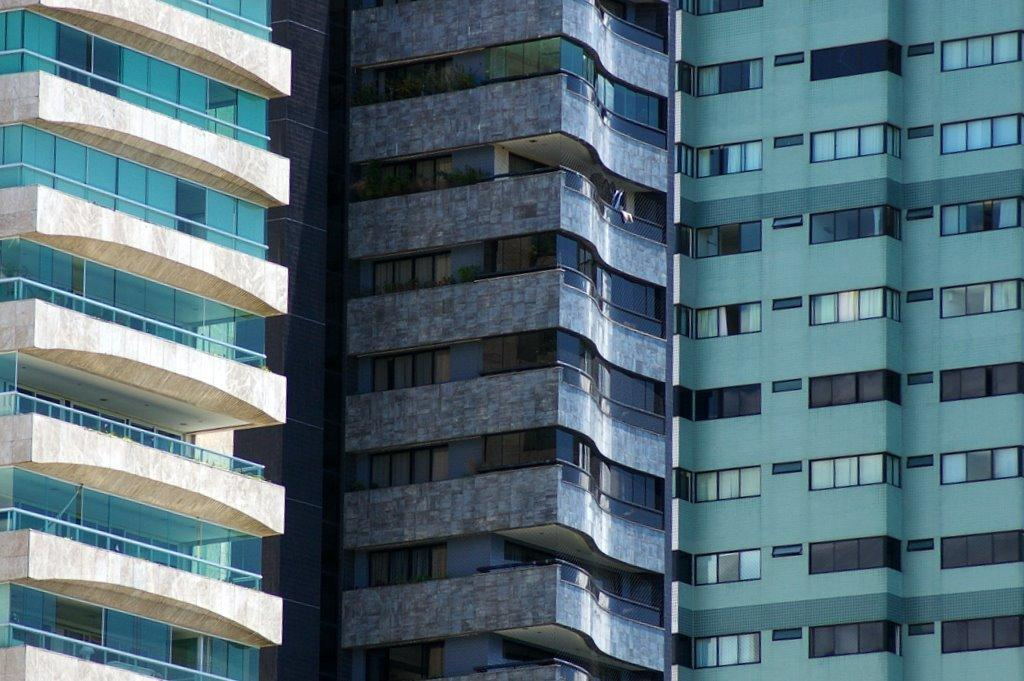What type of structures can be seen in the image? There are buildings in the image. What decision is being made by the face on the letter in the image? There is no face or letter present in the image; it only features buildings. 